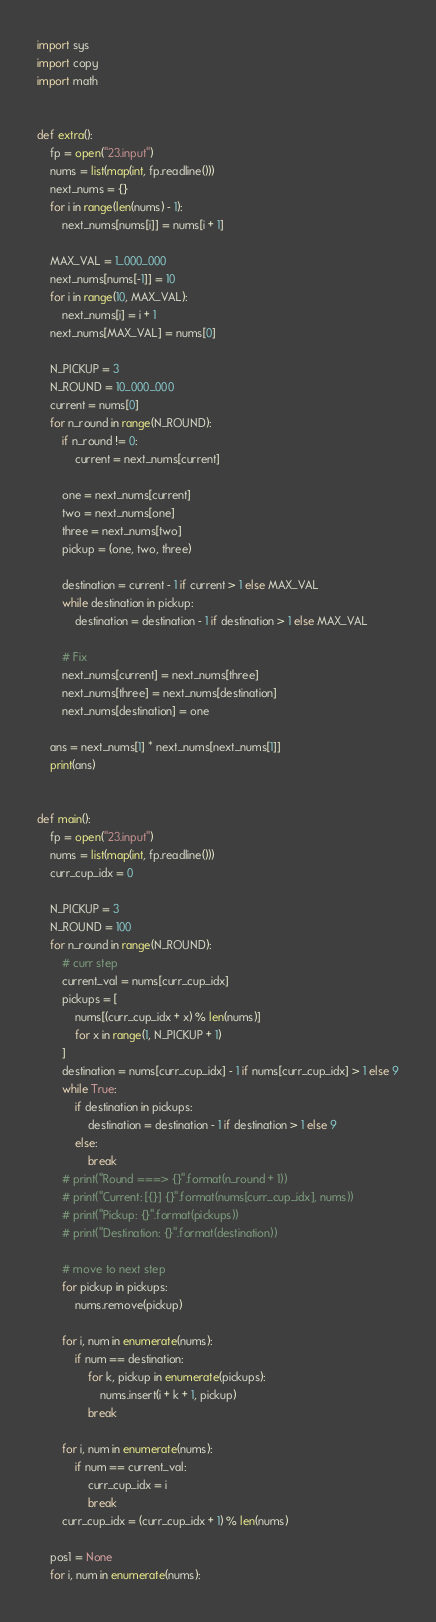Convert code to text. <code><loc_0><loc_0><loc_500><loc_500><_Python_>import sys
import copy
import math


def extra():
    fp = open("23.input")
    nums = list(map(int, fp.readline()))
    next_nums = {}
    for i in range(len(nums) - 1):
        next_nums[nums[i]] = nums[i + 1]

    MAX_VAL = 1_000_000
    next_nums[nums[-1]] = 10
    for i in range(10, MAX_VAL):
        next_nums[i] = i + 1
    next_nums[MAX_VAL] = nums[0]

    N_PICKUP = 3
    N_ROUND = 10_000_000
    current = nums[0]
    for n_round in range(N_ROUND):
        if n_round != 0:
            current = next_nums[current]

        one = next_nums[current]
        two = next_nums[one]
        three = next_nums[two]
        pickup = (one, two, three)

        destination = current - 1 if current > 1 else MAX_VAL
        while destination in pickup:
            destination = destination - 1 if destination > 1 else MAX_VAL

        # Fix
        next_nums[current] = next_nums[three]
        next_nums[three] = next_nums[destination]
        next_nums[destination] = one

    ans = next_nums[1] * next_nums[next_nums[1]]
    print(ans)


def main():
    fp = open("23.input")
    nums = list(map(int, fp.readline()))
    curr_cup_idx = 0

    N_PICKUP = 3
    N_ROUND = 100
    for n_round in range(N_ROUND):
        # curr step
        current_val = nums[curr_cup_idx]
        pickups = [
            nums[(curr_cup_idx + x) % len(nums)]
            for x in range(1, N_PICKUP + 1)
        ]
        destination = nums[curr_cup_idx] - 1 if nums[curr_cup_idx] > 1 else 9
        while True:
            if destination in pickups:
                destination = destination - 1 if destination > 1 else 9
            else:
                break
        # print("Round ===> {}".format(n_round + 1))
        # print("Current: [{}] {}".format(nums[curr_cup_idx], nums))
        # print("Pickup: {}".format(pickups))
        # print("Destination: {}".format(destination))

        # move to next step
        for pickup in pickups:
            nums.remove(pickup)

        for i, num in enumerate(nums):
            if num == destination:
                for k, pickup in enumerate(pickups):
                    nums.insert(i + k + 1, pickup)
                break

        for i, num in enumerate(nums):
            if num == current_val:
                curr_cup_idx = i
                break
        curr_cup_idx = (curr_cup_idx + 1) % len(nums)

    pos1 = None
    for i, num in enumerate(nums):</code> 